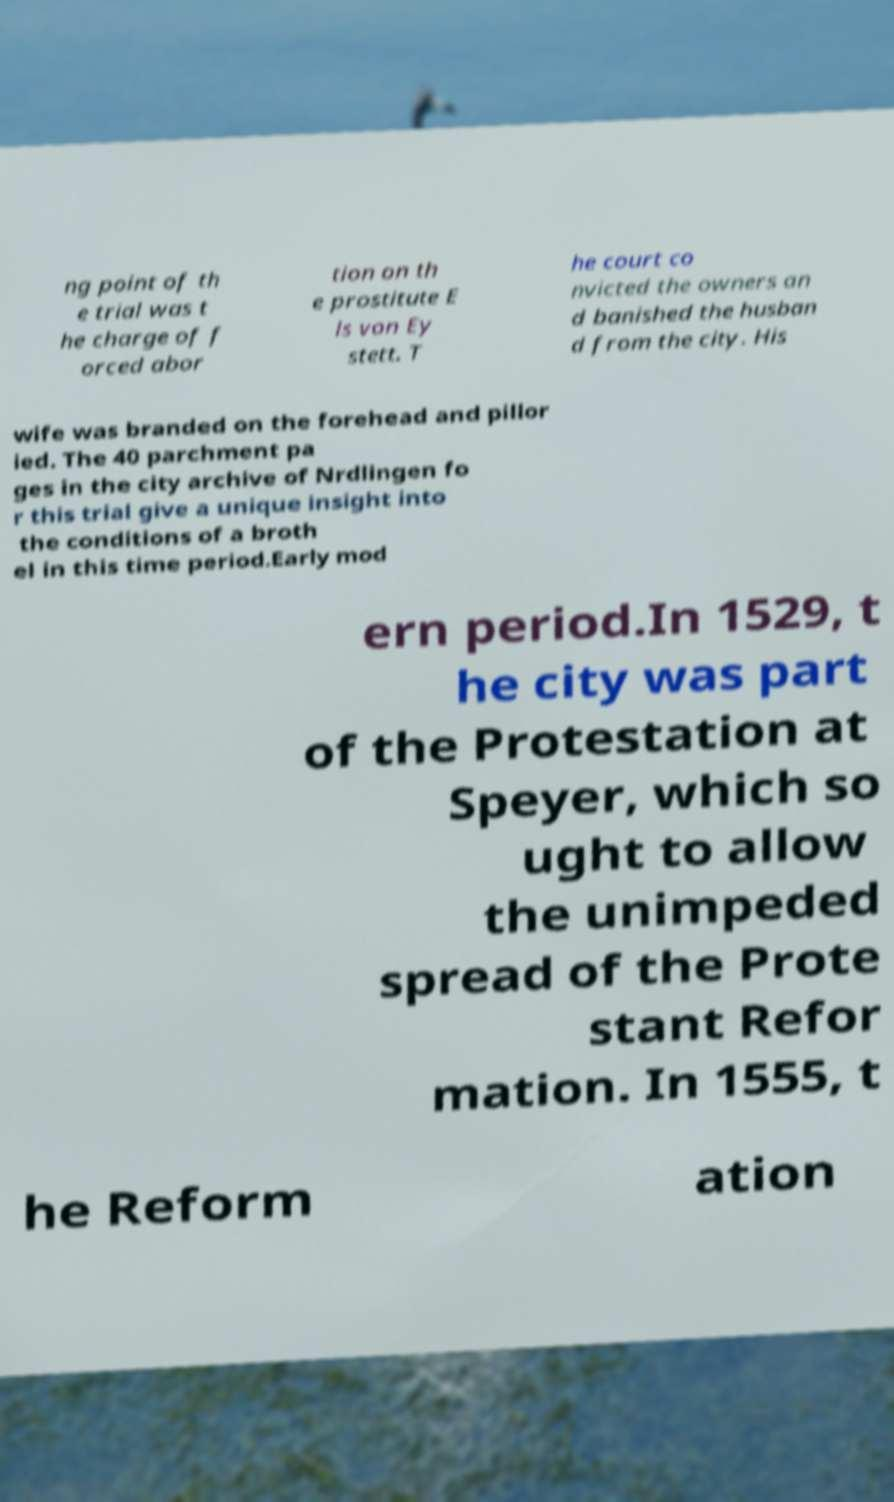Please read and relay the text visible in this image. What does it say? ng point of th e trial was t he charge of f orced abor tion on th e prostitute E ls von Ey stett. T he court co nvicted the owners an d banished the husban d from the city. His wife was branded on the forehead and pillor ied. The 40 parchment pa ges in the city archive of Nrdlingen fo r this trial give a unique insight into the conditions of a broth el in this time period.Early mod ern period.In 1529, t he city was part of the Protestation at Speyer, which so ught to allow the unimpeded spread of the Prote stant Refor mation. In 1555, t he Reform ation 